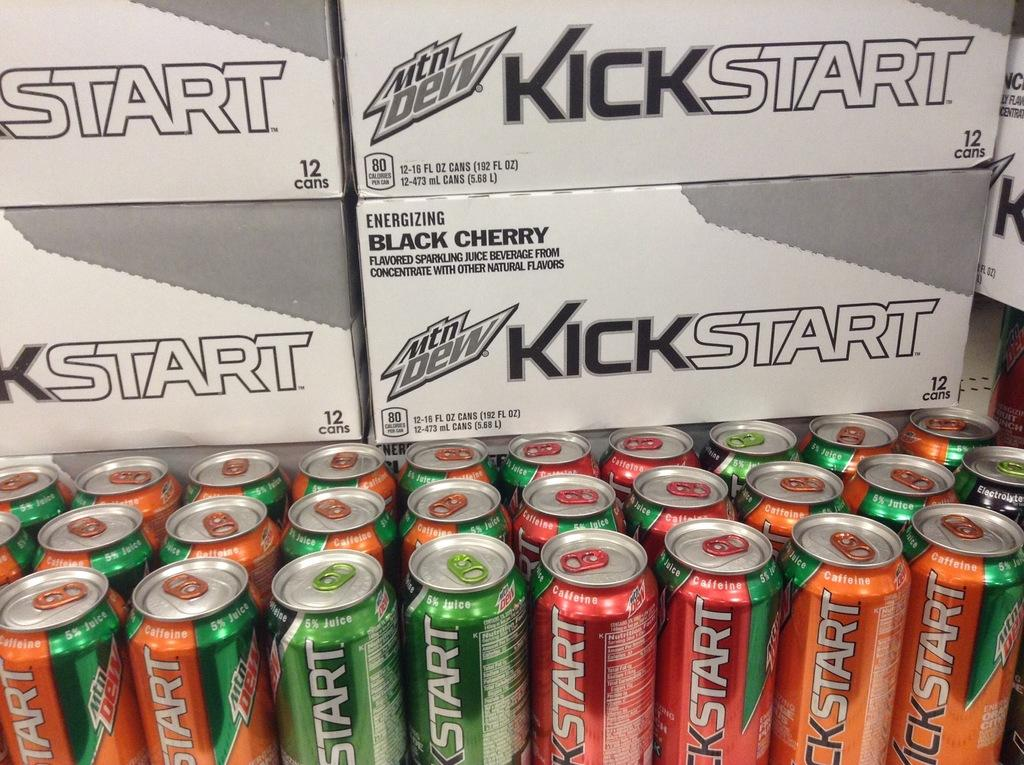<image>
Share a concise interpretation of the image provided. A case of black cherry Kickstart sits along with many cans of Kickstart. 